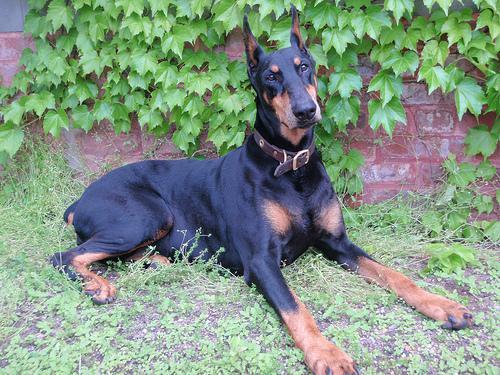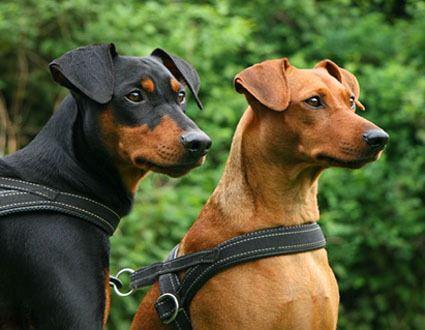The first image is the image on the left, the second image is the image on the right. Analyze the images presented: Is the assertion "The left image contains a left-facing dock-tailed dog standing in profile, with a handler behind it, and the right image contains one erect-eared dog wearing a chain collar." valid? Answer yes or no. No. The first image is the image on the left, the second image is the image on the right. Given the left and right images, does the statement "there is a doberman wearing a silver chain collar" hold true? Answer yes or no. No. 